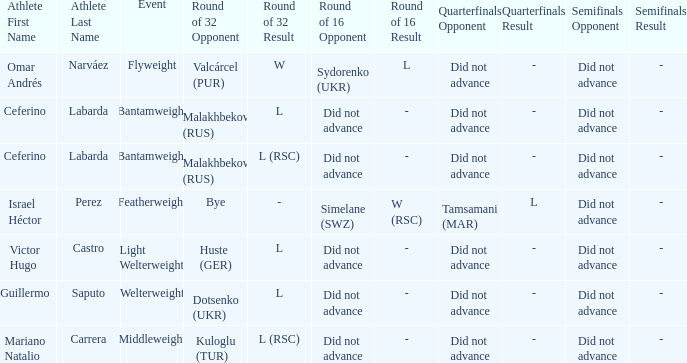Which athlete competed in the flyweight division? Omar Andrés Narváez. 